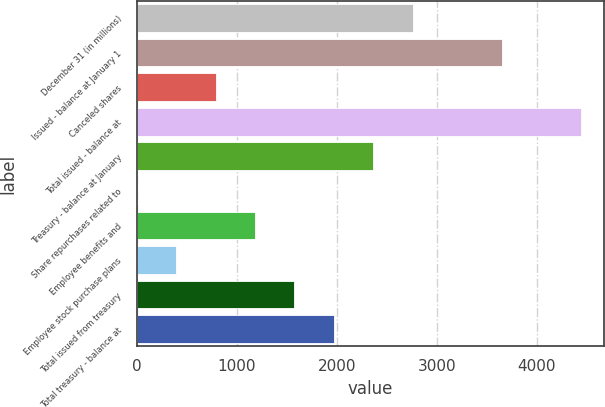<chart> <loc_0><loc_0><loc_500><loc_500><bar_chart><fcel>December 31 (in millions)<fcel>Issued - balance at January 1<fcel>Canceled shares<fcel>Total issued - balance at<fcel>Treasury - balance at January<fcel>Share repurchases related to<fcel>Employee benefits and<fcel>Employee stock purchase plans<fcel>Total issued from treasury<fcel>Total treasury - balance at<nl><fcel>2759.27<fcel>3657.7<fcel>788.72<fcel>4445.92<fcel>2365.16<fcel>0.5<fcel>1182.83<fcel>394.61<fcel>1576.94<fcel>1971.05<nl></chart> 